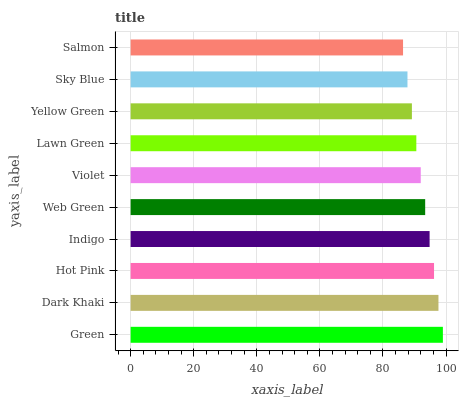Is Salmon the minimum?
Answer yes or no. Yes. Is Green the maximum?
Answer yes or no. Yes. Is Dark Khaki the minimum?
Answer yes or no. No. Is Dark Khaki the maximum?
Answer yes or no. No. Is Green greater than Dark Khaki?
Answer yes or no. Yes. Is Dark Khaki less than Green?
Answer yes or no. Yes. Is Dark Khaki greater than Green?
Answer yes or no. No. Is Green less than Dark Khaki?
Answer yes or no. No. Is Web Green the high median?
Answer yes or no. Yes. Is Violet the low median?
Answer yes or no. Yes. Is Hot Pink the high median?
Answer yes or no. No. Is Indigo the low median?
Answer yes or no. No. 